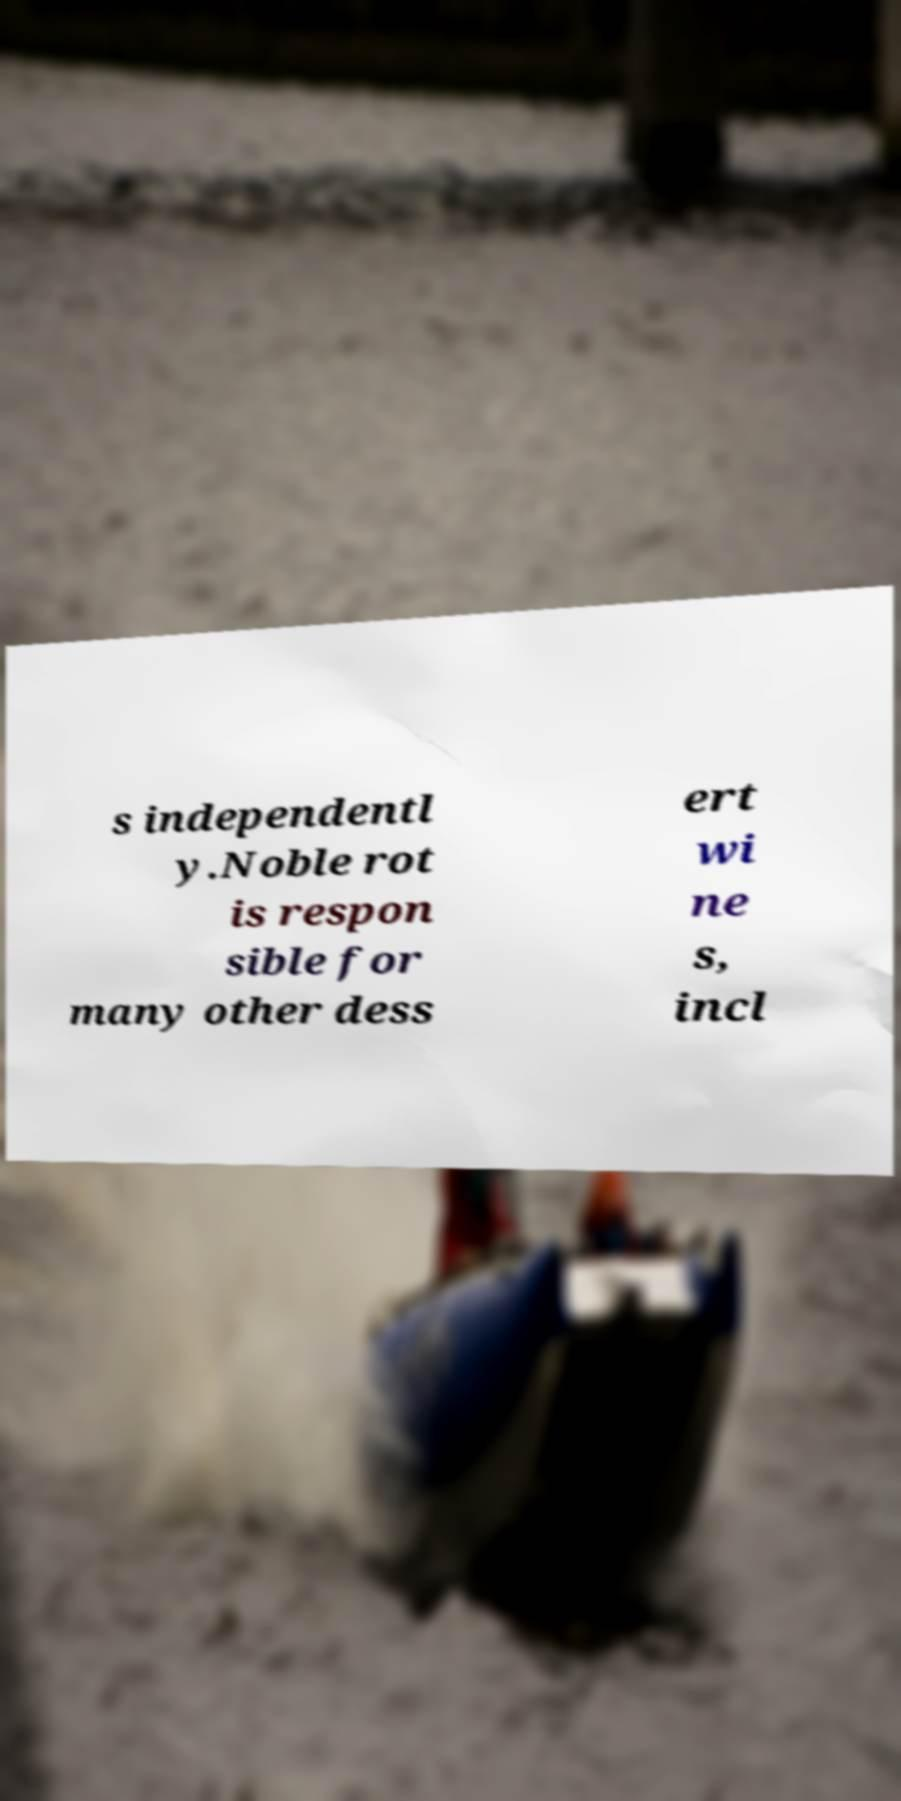For documentation purposes, I need the text within this image transcribed. Could you provide that? s independentl y.Noble rot is respon sible for many other dess ert wi ne s, incl 